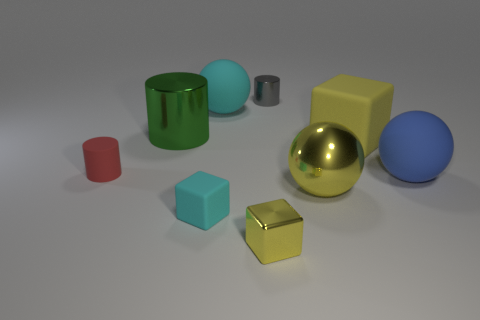There is a large ball that is both behind the yellow shiny ball and on the left side of the large yellow rubber thing; what is its color?
Make the answer very short. Cyan. The cylinder that is to the right of the shiny cylinder that is to the left of the tiny yellow thing is made of what material?
Your answer should be compact. Metal. Is the cyan rubber ball the same size as the gray metallic object?
Offer a very short reply. No. What number of big objects are cyan rubber cylinders or yellow metallic blocks?
Keep it short and to the point. 0. There is a large cyan sphere; what number of cylinders are on the left side of it?
Your response must be concise. 2. Are there more big objects that are on the right side of the yellow ball than large cyan balls?
Provide a succinct answer. Yes. There is a tiny yellow thing that is made of the same material as the big yellow sphere; what is its shape?
Provide a succinct answer. Cube. There is a tiny block on the left side of the sphere that is behind the tiny red matte cylinder; what is its color?
Ensure brevity in your answer.  Cyan. Do the tiny red thing and the small cyan thing have the same shape?
Ensure brevity in your answer.  No. There is a small gray thing that is the same shape as the large green thing; what is it made of?
Provide a succinct answer. Metal. 